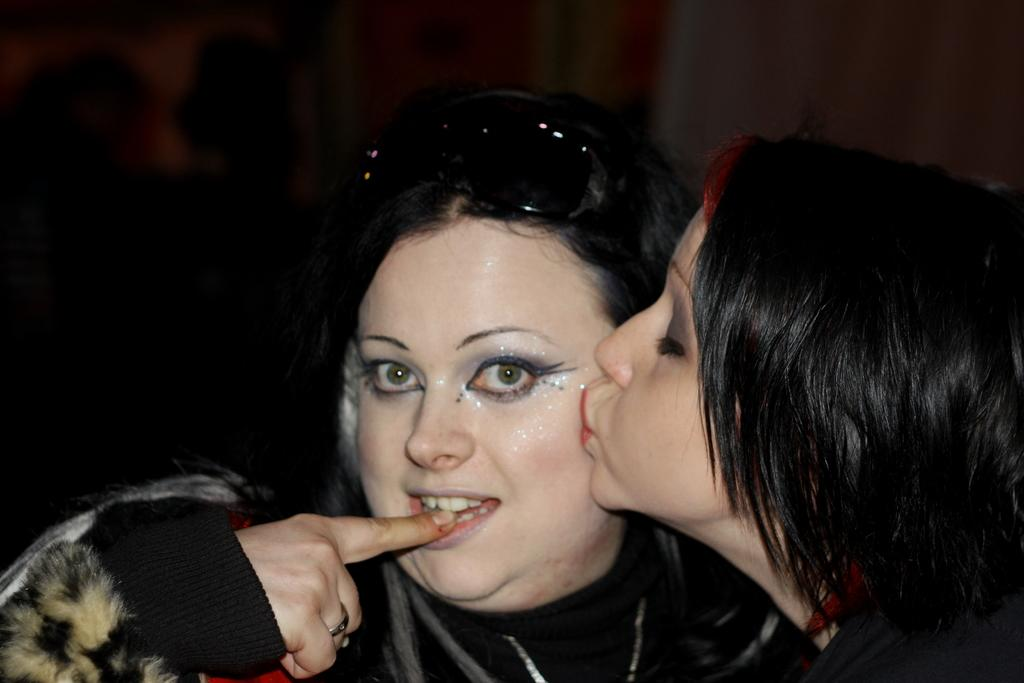What is the girl doing in the image? The girl is kissing a woman in the image. What objects are present in the image besides the girl and the woman? There is no information about other objects in the image. Can you describe the setting or location of the image? There is no information about the setting or location of the image. What type of fang can be seen in the image? There is no fang present in the image. What industry is depicted in the image? There is no industry depicted in the image. 